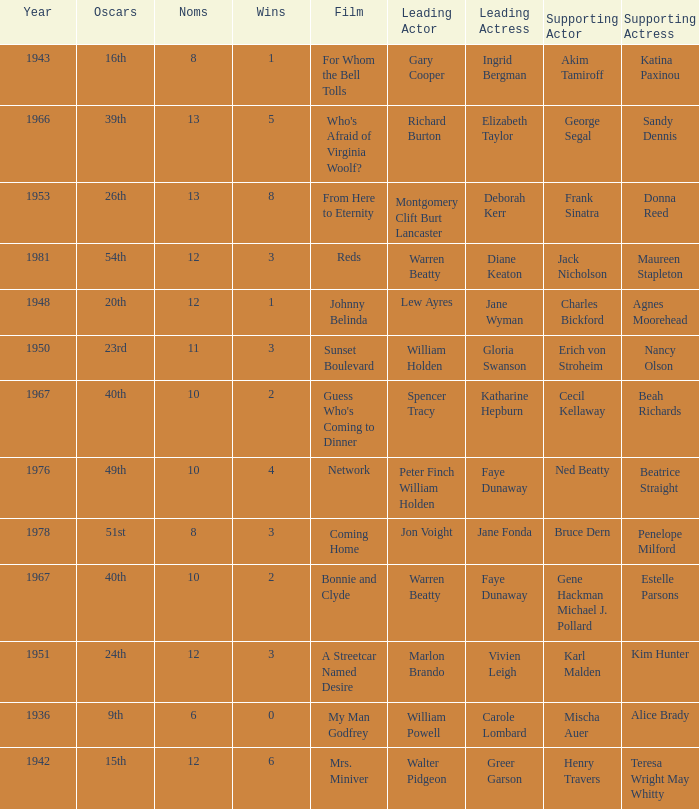Who was the supporting actress in "For Whom the Bell Tolls"? Katina Paxinou. 